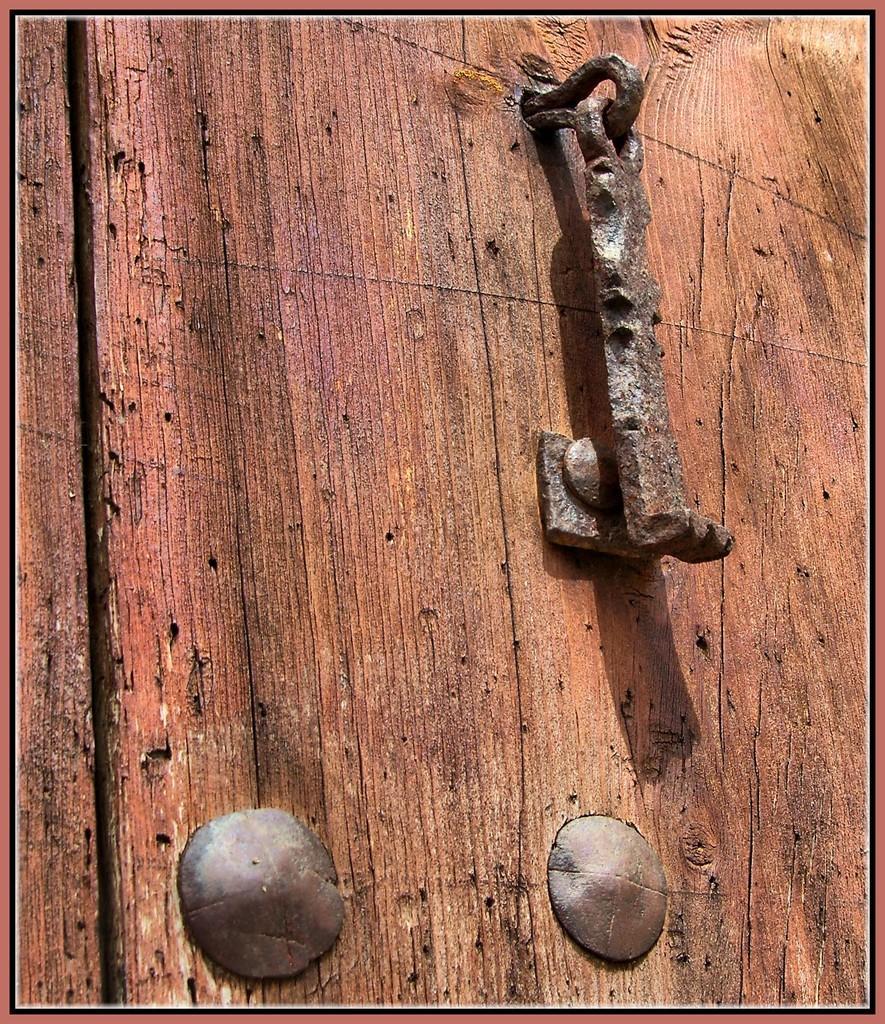In one or two sentences, can you explain what this image depicts? In this image it looks like there is a door and on it there is a metallic object which looks a door lock. 